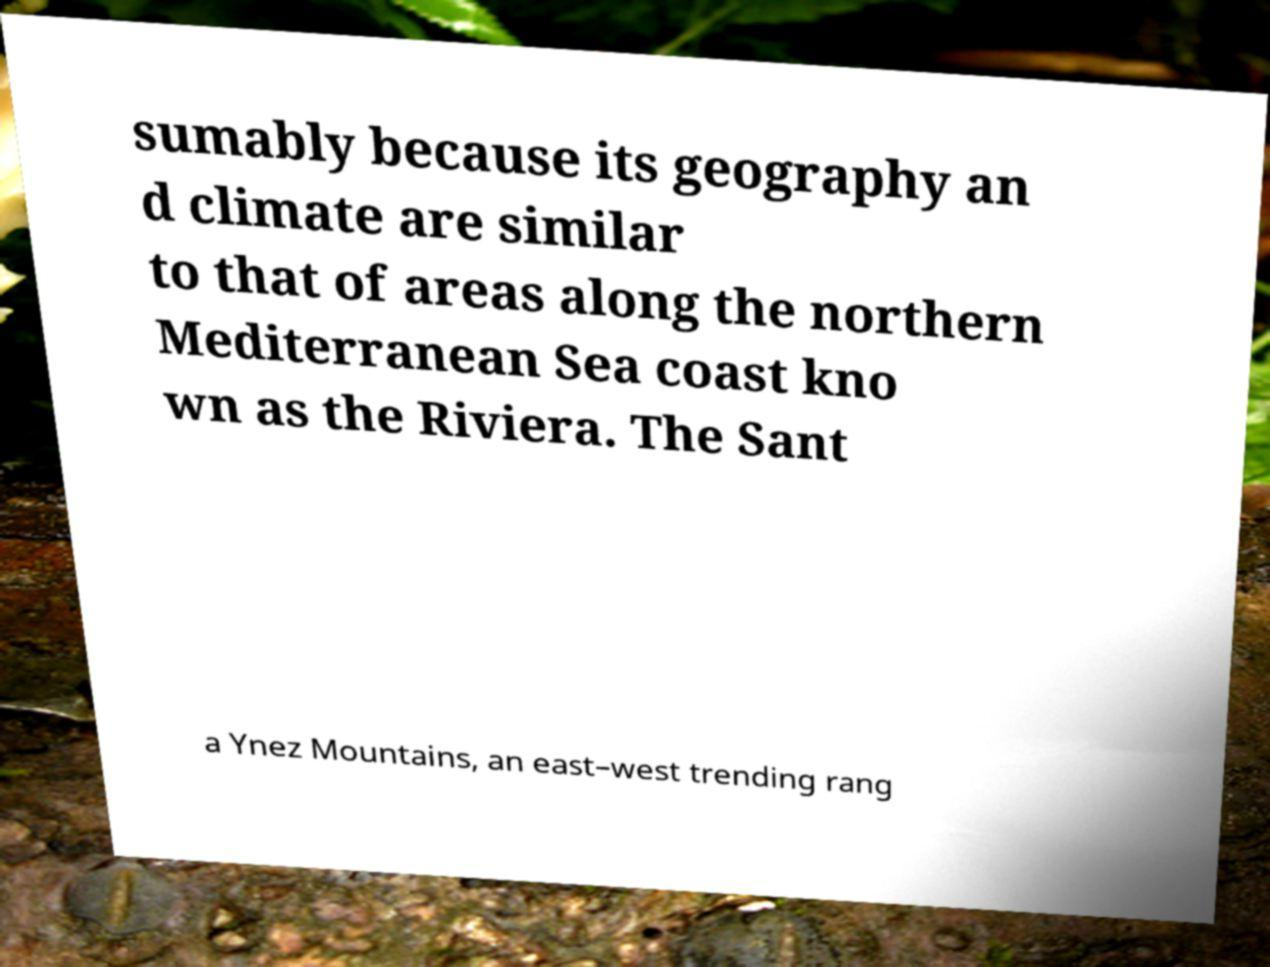Please read and relay the text visible in this image. What does it say? sumably because its geography an d climate are similar to that of areas along the northern Mediterranean Sea coast kno wn as the Riviera. The Sant a Ynez Mountains, an east–west trending rang 